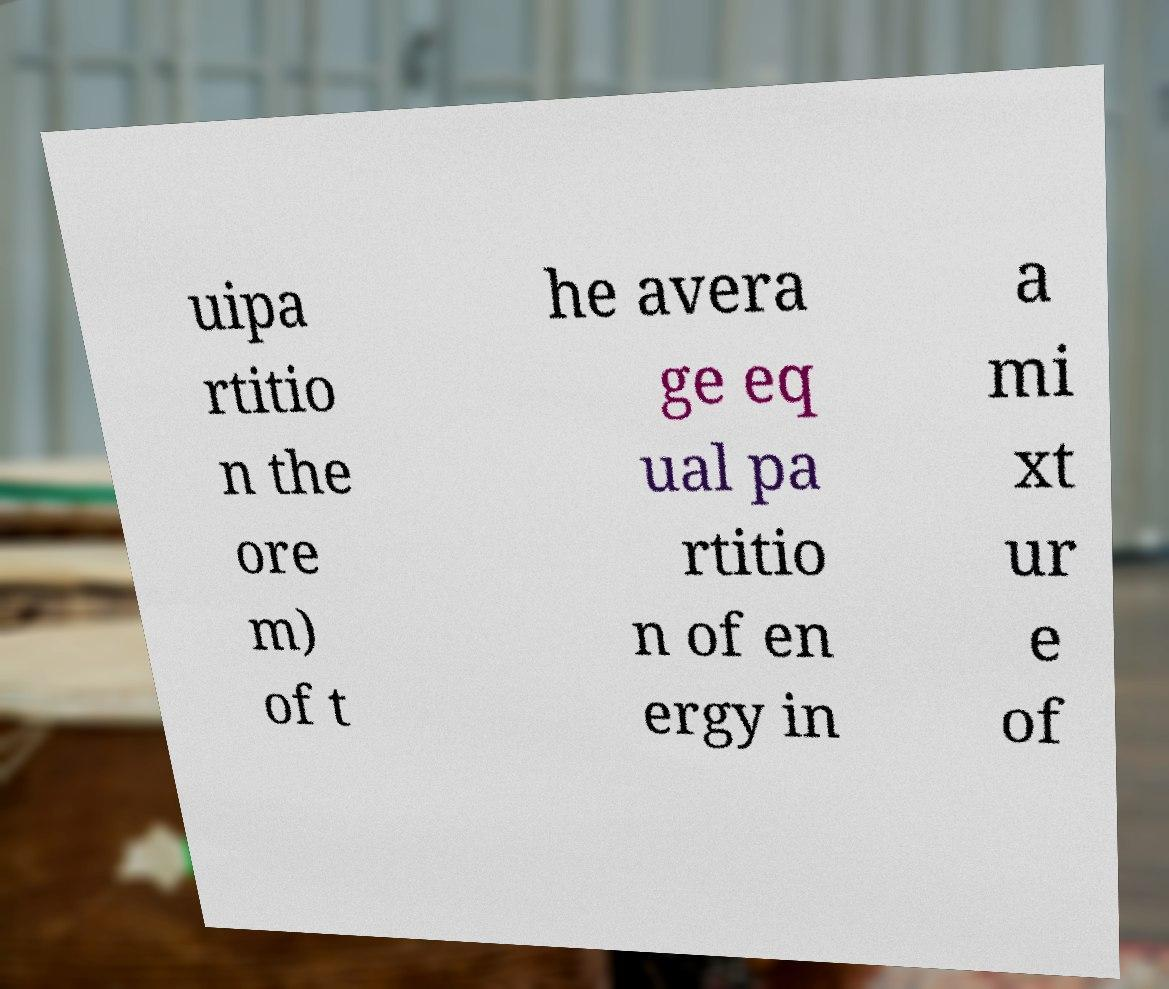Could you assist in decoding the text presented in this image and type it out clearly? uipa rtitio n the ore m) of t he avera ge eq ual pa rtitio n of en ergy in a mi xt ur e of 